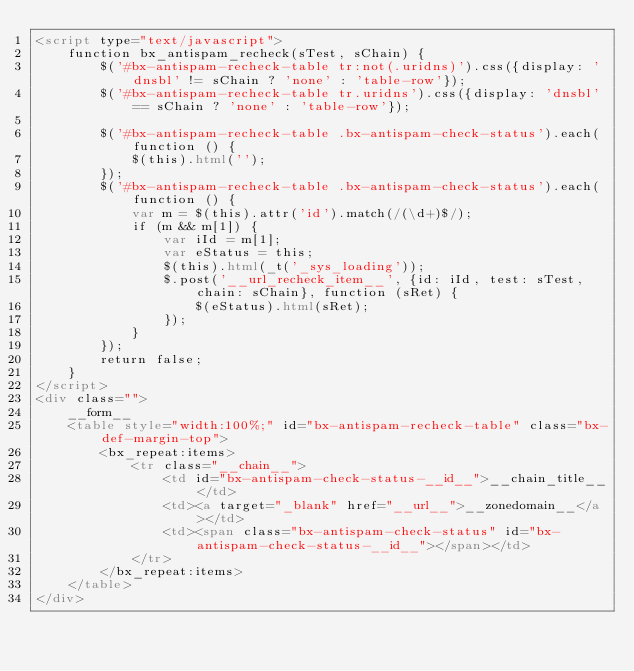<code> <loc_0><loc_0><loc_500><loc_500><_HTML_><script type="text/javascript">
    function bx_antispam_recheck(sTest, sChain) {
        $('#bx-antispam-recheck-table tr:not(.uridns)').css({display: 'dnsbl' != sChain ? 'none' : 'table-row'});
        $('#bx-antispam-recheck-table tr.uridns').css({display: 'dnsbl' == sChain ? 'none' : 'table-row'});

        $('#bx-antispam-recheck-table .bx-antispam-check-status').each(function () {
            $(this).html('');
        });
        $('#bx-antispam-recheck-table .bx-antispam-check-status').each(function () {
            var m = $(this).attr('id').match(/(\d+)$/);
            if (m && m[1]) {
                var iId = m[1];
                var eStatus = this;
                $(this).html(_t('_sys_loading'));
                $.post('__url_recheck_item__', {id: iId, test: sTest, chain: sChain}, function (sRet) {
                    $(eStatus).html(sRet);
                });
            }
        });
        return false;
    }
</script>
<div class="">
    __form__
    <table style="width:100%;" id="bx-antispam-recheck-table" class="bx-def-margin-top">
        <bx_repeat:items>
            <tr class="__chain__">
                <td id="bx-antispam-check-status-__id__">__chain_title__</td>
                <td><a target="_blank" href="__url__">__zonedomain__</a></td>
                <td><span class="bx-antispam-check-status" id="bx-antispam-check-status-__id__"></span></td>
            </tr>
        </bx_repeat:items>
    </table>        
</div>
</code> 